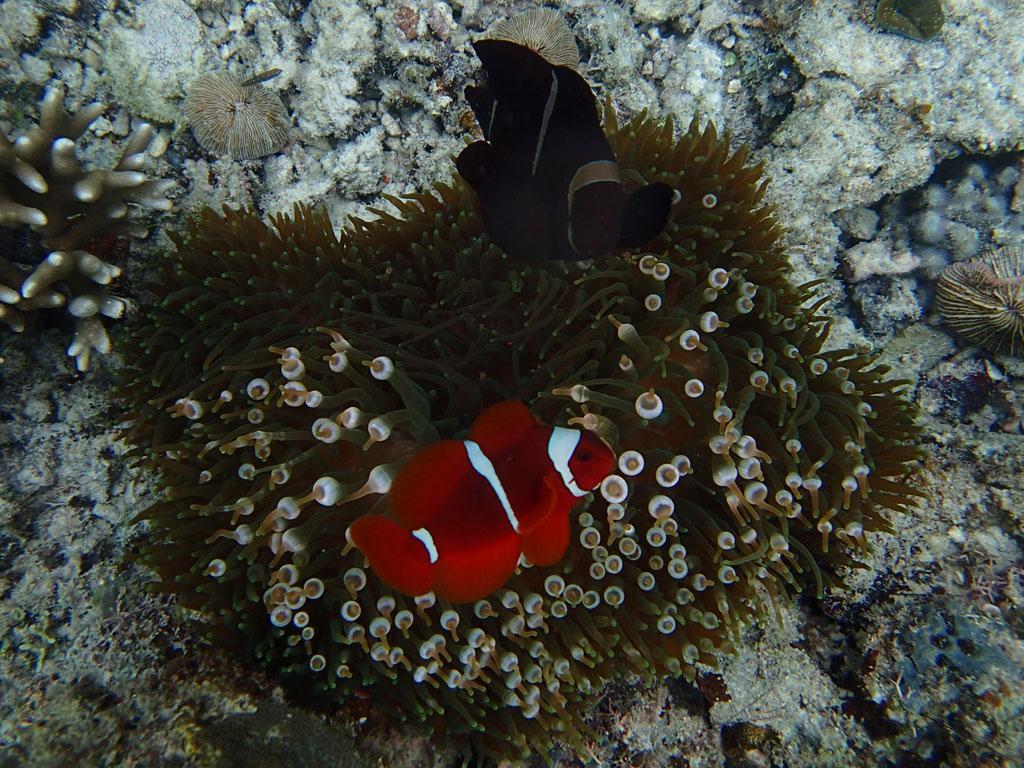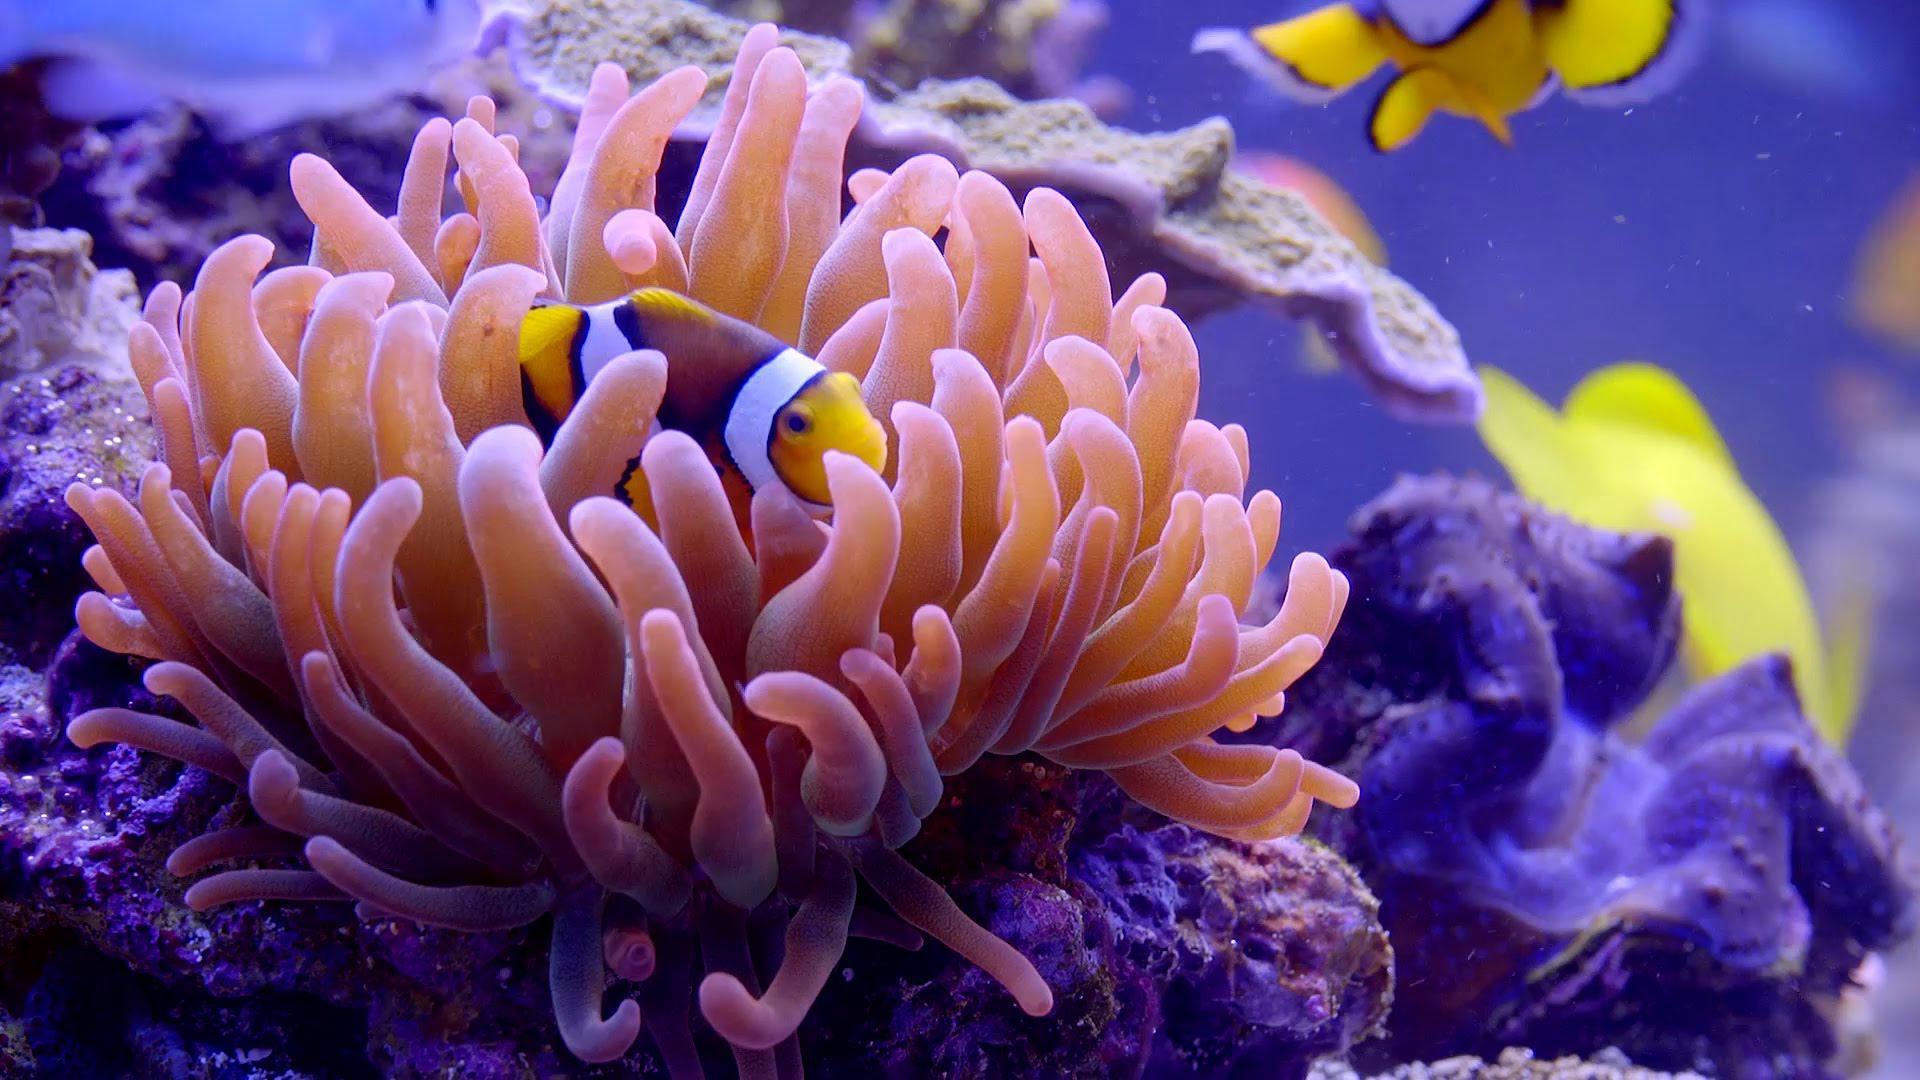The first image is the image on the left, the second image is the image on the right. For the images displayed, is the sentence "One image shows bright yellow-orange clown fish with white stripes in and near anemone tendrils with a pinkish hue." factually correct? Answer yes or no. Yes. 